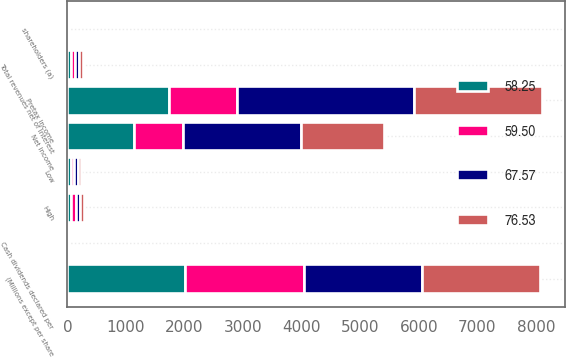Convert chart to OTSL. <chart><loc_0><loc_0><loc_500><loc_500><stacked_bar_chart><ecel><fcel>(Millions except per share<fcel>Total revenues net of interest<fcel>Pretax income<fcel>Net income<fcel>shareholders (a)<fcel>Cash dividends declared per<fcel>High<fcel>Low<nl><fcel>59.5<fcel>2016<fcel>67.76<fcel>1161<fcel>825<fcel>0.88<fcel>0.32<fcel>75.74<fcel>59.5<nl><fcel>58.25<fcel>2016<fcel>67.76<fcel>1735<fcel>1142<fcel>1.21<fcel>0.32<fcel>66.71<fcel>58.25<nl><fcel>67.57<fcel>2016<fcel>67.76<fcel>3016<fcel>2015<fcel>2.11<fcel>0.29<fcel>67.34<fcel>57.15<nl><fcel>76.53<fcel>2016<fcel>67.76<fcel>2184<fcel>1426<fcel>1.45<fcel>0.29<fcel>68.18<fcel>50.27<nl></chart> 